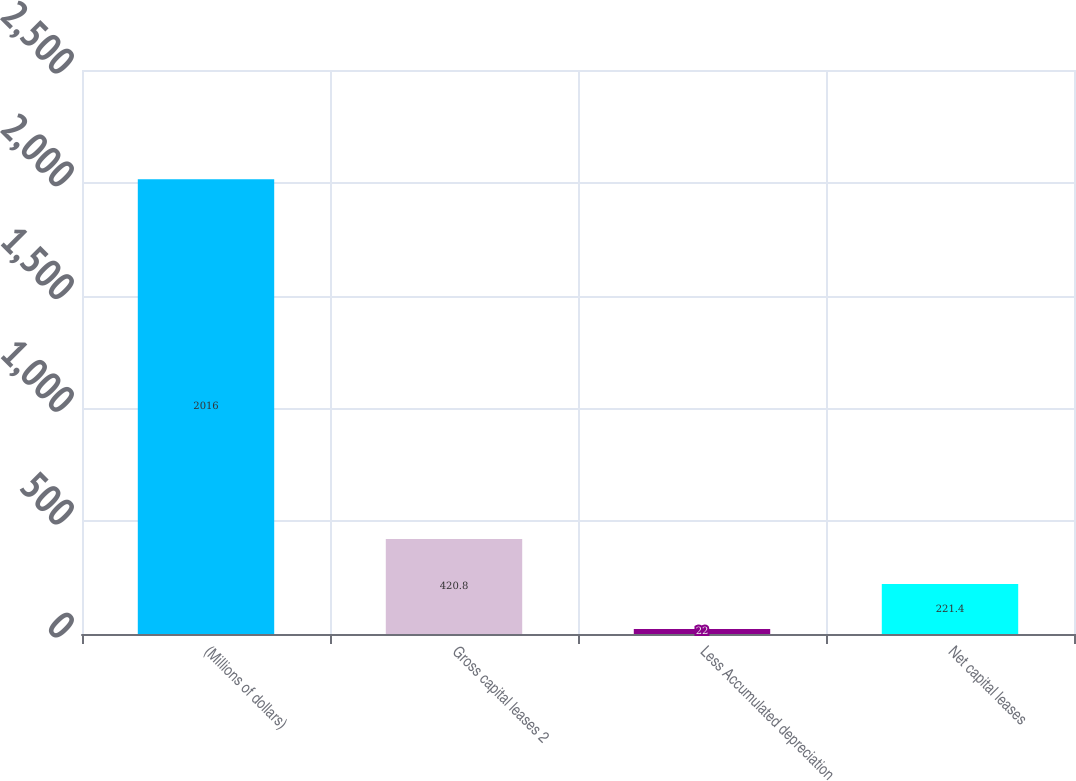<chart> <loc_0><loc_0><loc_500><loc_500><bar_chart><fcel>(Millions of dollars)<fcel>Gross capital leases 2<fcel>Less Accumulated depreciation<fcel>Net capital leases<nl><fcel>2016<fcel>420.8<fcel>22<fcel>221.4<nl></chart> 